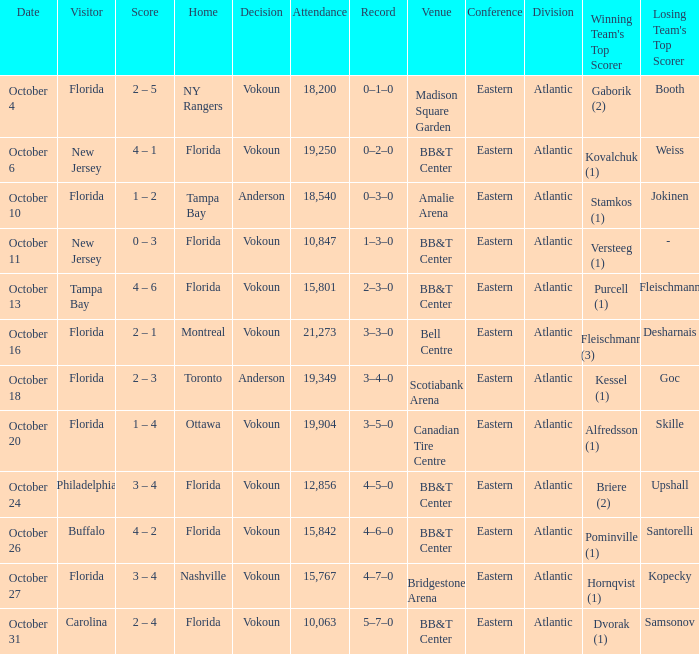What was the count on october 31? 2 – 4. 